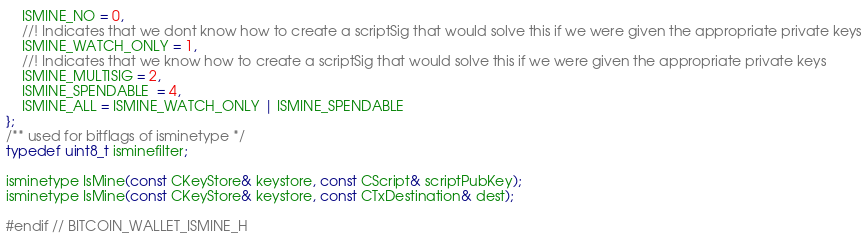Convert code to text. <code><loc_0><loc_0><loc_500><loc_500><_C_>    ISMINE_NO = 0,
    //! Indicates that we dont know how to create a scriptSig that would solve this if we were given the appropriate private keys
    ISMINE_WATCH_ONLY = 1,
    //! Indicates that we know how to create a scriptSig that would solve this if we were given the appropriate private keys
    ISMINE_MULTISIG = 2,
    ISMINE_SPENDABLE  = 4,
    ISMINE_ALL = ISMINE_WATCH_ONLY | ISMINE_SPENDABLE
};
/** used for bitflags of isminetype */
typedef uint8_t isminefilter;

isminetype IsMine(const CKeyStore& keystore, const CScript& scriptPubKey);
isminetype IsMine(const CKeyStore& keystore, const CTxDestination& dest);

#endif // BITCOIN_WALLET_ISMINE_H
</code> 